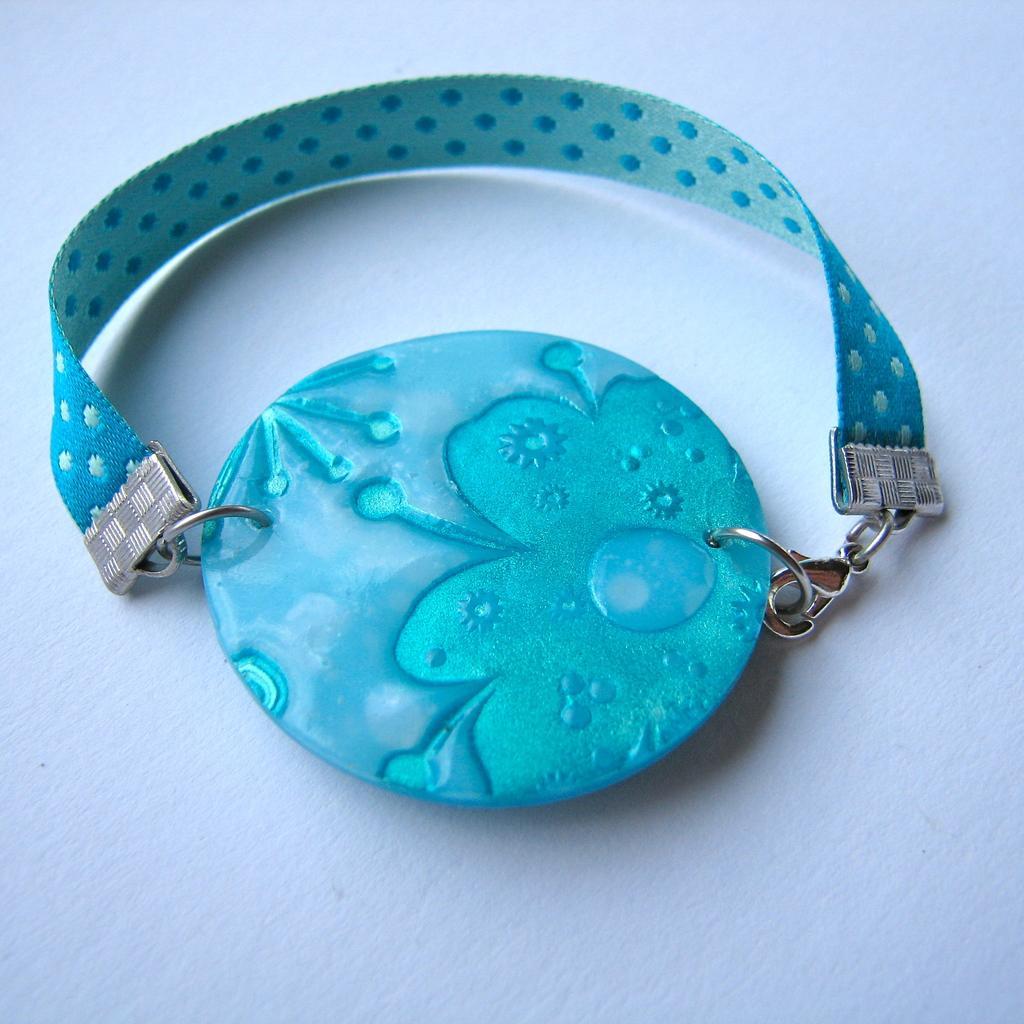Please provide a concise description of this image. This is the picture of a chain to which there is a locket and it is in blue color. 